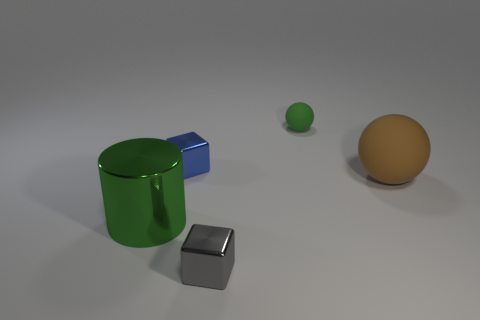What shape is the green thing that is the same size as the brown object?
Your response must be concise. Cylinder. Is there a tiny gray object that is in front of the small object right of the cube to the right of the small blue shiny object?
Provide a succinct answer. Yes. Is there another object that has the same size as the blue metallic thing?
Provide a succinct answer. Yes. There is a green rubber ball right of the blue metal object; what size is it?
Your answer should be compact. Small. What color is the block that is to the left of the small cube that is in front of the small shiny block that is behind the cylinder?
Make the answer very short. Blue. The sphere to the right of the small green ball that is behind the brown object is what color?
Ensure brevity in your answer.  Brown. Are there more big spheres that are on the left side of the green matte thing than tiny rubber spheres left of the large brown matte thing?
Give a very brief answer. No. Is the material of the large thing left of the tiny green ball the same as the thing that is on the right side of the tiny ball?
Offer a very short reply. No. Are there any metallic objects behind the small blue block?
Your answer should be compact. No. How many yellow objects are tiny matte things or cylinders?
Provide a succinct answer. 0. 